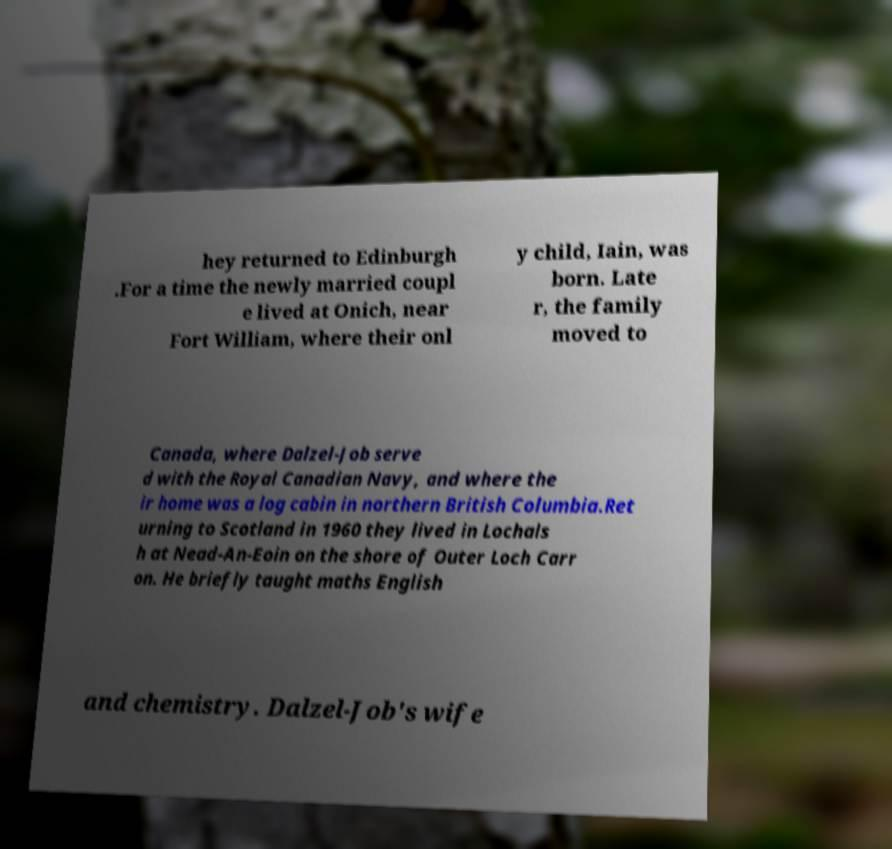Can you read and provide the text displayed in the image?This photo seems to have some interesting text. Can you extract and type it out for me? hey returned to Edinburgh .For a time the newly married coupl e lived at Onich, near Fort William, where their onl y child, Iain, was born. Late r, the family moved to Canada, where Dalzel-Job serve d with the Royal Canadian Navy, and where the ir home was a log cabin in northern British Columbia.Ret urning to Scotland in 1960 they lived in Lochals h at Nead-An-Eoin on the shore of Outer Loch Carr on. He briefly taught maths English and chemistry. Dalzel-Job's wife 